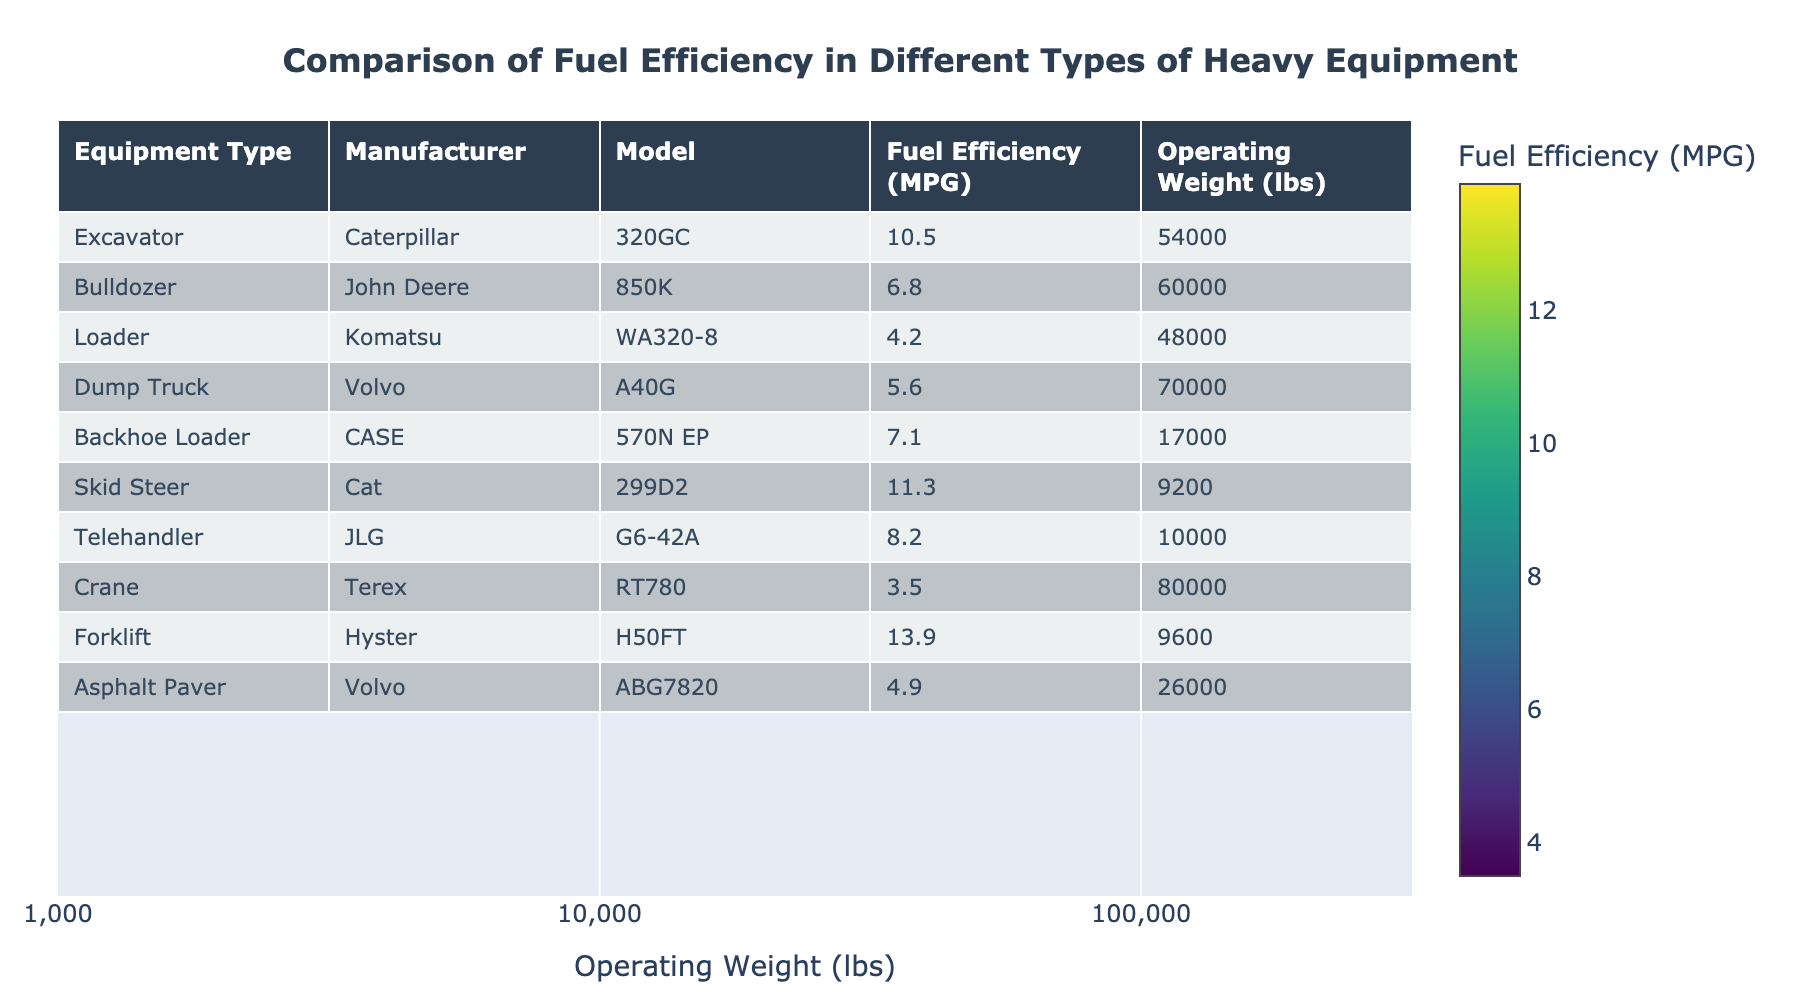What is the fuel efficiency of the Caterpillar 320GC excavator? The table clearly shows the fuel efficiency for the Caterpillar 320GC under the "Fuel Efficiency (MPG)" column. The value listed is 10.5 MPG.
Answer: 10.5 MPG Which equipment type has the lowest fuel efficiency? To find the lowest fuel efficiency, I will compare the values in the "Fuel Efficiency (MPG)" column. The lowest value listed is for the Terex RT780 crane, which has a fuel efficiency of 3.5 MPG.
Answer: Terex RT780 crane Calculate the average fuel efficiency of all equipment types. To find the average, I will sum the fuel efficiency values: (10.5 + 6.8 + 4.2 + 5.6 + 7.1 + 11.3 + 8.2 + 3.5 + 13.9 + 4.9) = 70.1. There are 10 types of equipment, so the average is 70.1 / 10 = 7.01 MPG.
Answer: 7.01 MPG Do any loaders have better fuel efficiency than backhoe loaders? Checking the values, the fuel efficiency for the Komatsu WA320-8 loader is 4.2 MPG, while the CASE 570N EP backhoe loader has a fuel efficiency of 7.1 MPG. Therefore, no loaders have better fuel efficiency than backhoe loaders.
Answer: No Which equipment type has the highest fuel efficiency and what is its value? Looking at the "Fuel Efficiency (MPG)" column, the highest value is found for the Hyster H50FT forklift, which has 13.9 MPG.
Answer: Hyster H50FT forklift, 13.9 MPG If we combine the fuel efficiency of the two bulldozer models in the data, what is their total? The data contains only one bulldozer model: the John Deere 850K with a fuel efficiency of 6.8 MPG. Thus, the total fuel efficiency for bulldozers is simply 6.8 MPG.
Answer: 6.8 MPG Is the average operating weight of the cranes greater than 75,000 lbs? The operating weight for the Terex RT780 crane is 80,000 lbs. Since there is only one crane in the data, the average is also 80,000 lbs, which is indeed greater than 75,000 lbs.
Answer: Yes What is the difference in fuel efficiency between the highest and lowest values? The highest fuel efficiency is 13.9 MPG (forklift), and the lowest is 3.5 MPG (crane). The difference is 13.9 - 3.5 = 10.4 MPG.
Answer: 10.4 MPG 